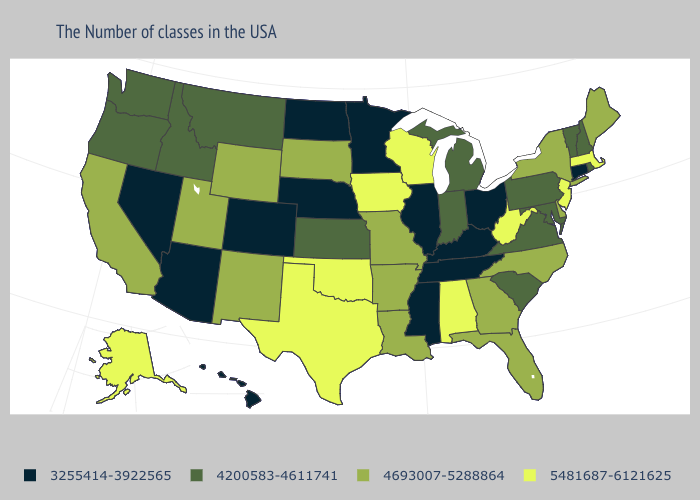What is the value of New Hampshire?
Answer briefly. 4200583-4611741. Does Alaska have a higher value than Texas?
Keep it brief. No. Is the legend a continuous bar?
Give a very brief answer. No. What is the value of South Dakota?
Give a very brief answer. 4693007-5288864. What is the value of New Hampshire?
Answer briefly. 4200583-4611741. Name the states that have a value in the range 3255414-3922565?
Write a very short answer. Connecticut, Ohio, Kentucky, Tennessee, Illinois, Mississippi, Minnesota, Nebraska, North Dakota, Colorado, Arizona, Nevada, Hawaii. What is the value of Iowa?
Give a very brief answer. 5481687-6121625. What is the value of Illinois?
Short answer required. 3255414-3922565. Among the states that border Oregon , does California have the highest value?
Be succinct. Yes. What is the value of Wyoming?
Be succinct. 4693007-5288864. Which states hav the highest value in the South?
Answer briefly. West Virginia, Alabama, Oklahoma, Texas. What is the highest value in the South ?
Short answer required. 5481687-6121625. Among the states that border Idaho , does Montana have the highest value?
Answer briefly. No. Name the states that have a value in the range 4693007-5288864?
Quick response, please. Maine, New York, Delaware, North Carolina, Florida, Georgia, Louisiana, Missouri, Arkansas, South Dakota, Wyoming, New Mexico, Utah, California. Among the states that border Utah , which have the highest value?
Short answer required. Wyoming, New Mexico. 